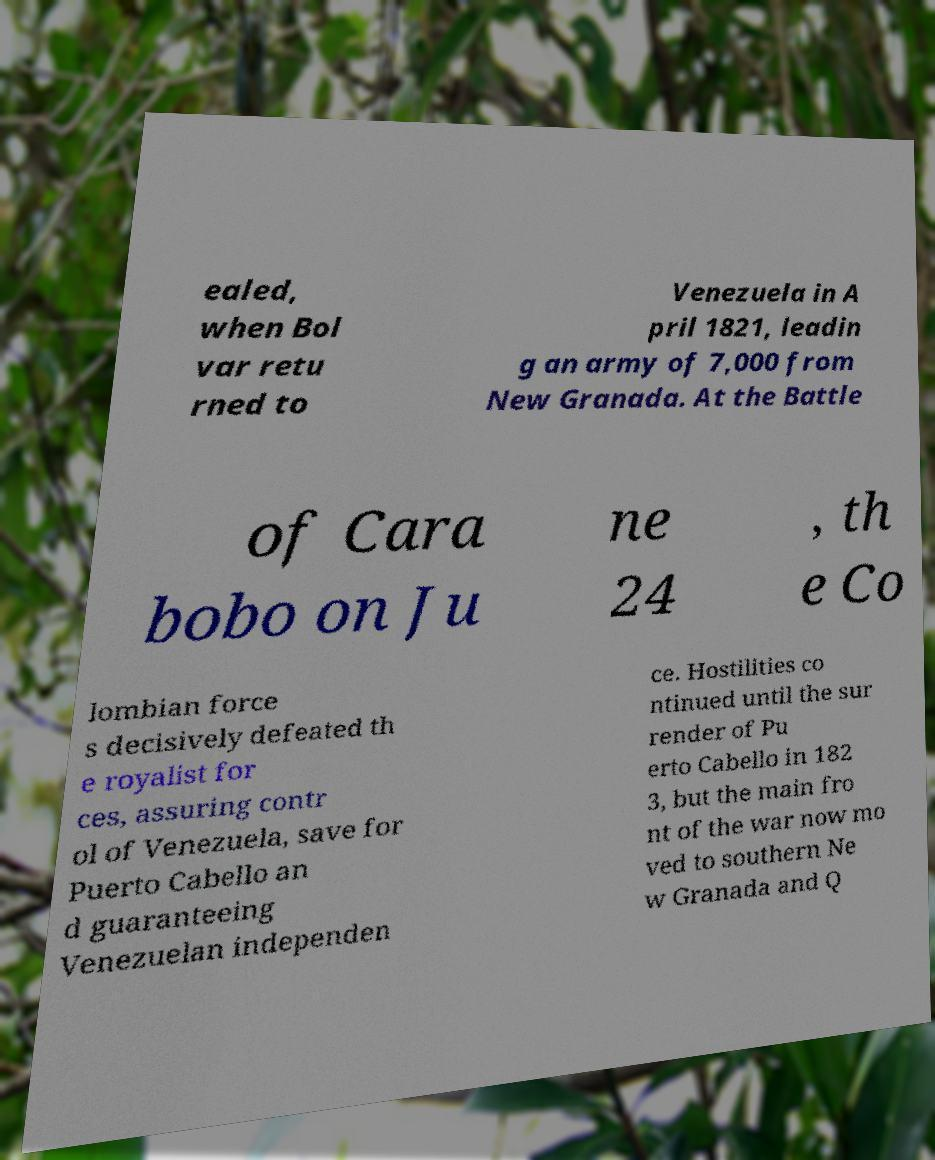For documentation purposes, I need the text within this image transcribed. Could you provide that? ealed, when Bol var retu rned to Venezuela in A pril 1821, leadin g an army of 7,000 from New Granada. At the Battle of Cara bobo on Ju ne 24 , th e Co lombian force s decisively defeated th e royalist for ces, assuring contr ol of Venezuela, save for Puerto Cabello an d guaranteeing Venezuelan independen ce. Hostilities co ntinued until the sur render of Pu erto Cabello in 182 3, but the main fro nt of the war now mo ved to southern Ne w Granada and Q 